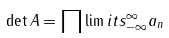Convert formula to latex. <formula><loc_0><loc_0><loc_500><loc_500>\det A = \prod \lim i t s _ { - \infty } ^ { \infty } a _ { n }</formula> 